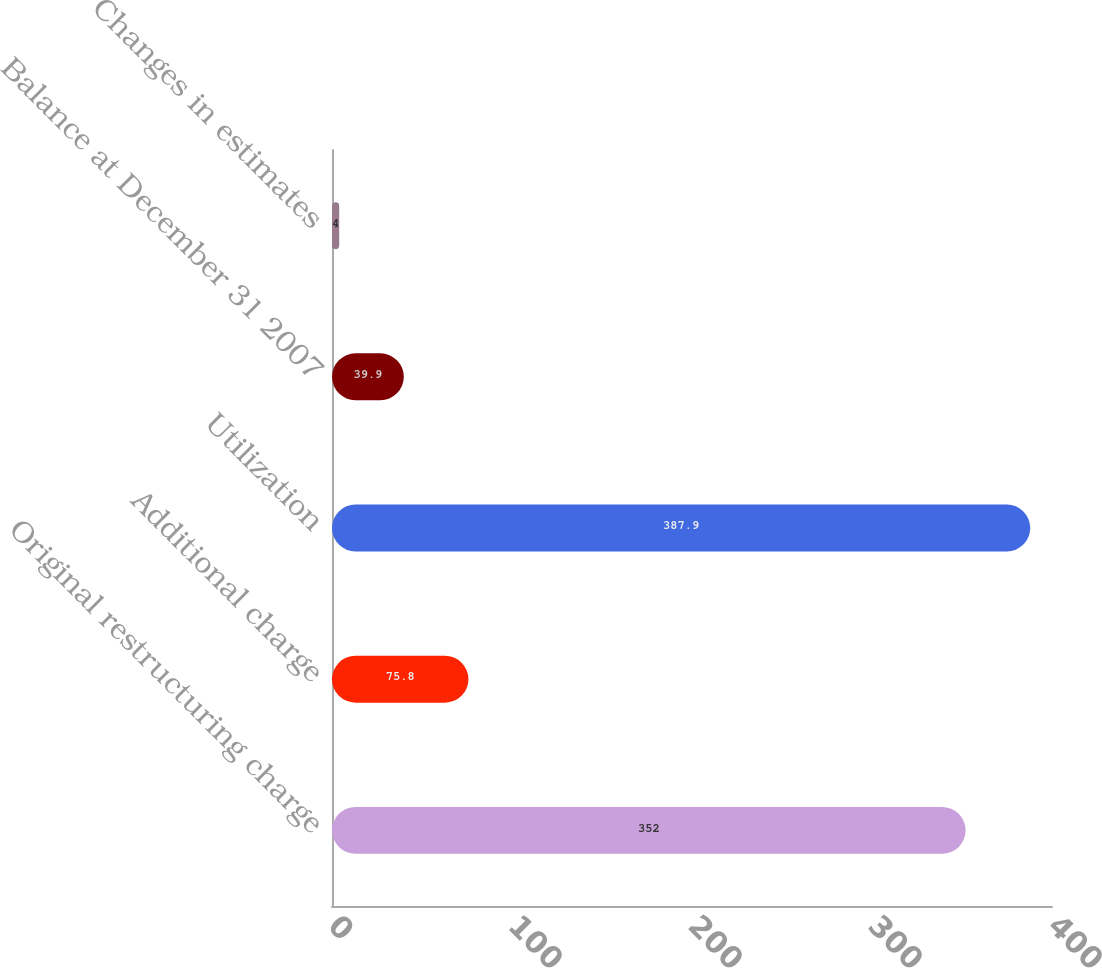Convert chart to OTSL. <chart><loc_0><loc_0><loc_500><loc_500><bar_chart><fcel>Original restructuring charge<fcel>Additional charge<fcel>Utilization<fcel>Balance at December 31 2007<fcel>Changes in estimates<nl><fcel>352<fcel>75.8<fcel>387.9<fcel>39.9<fcel>4<nl></chart> 